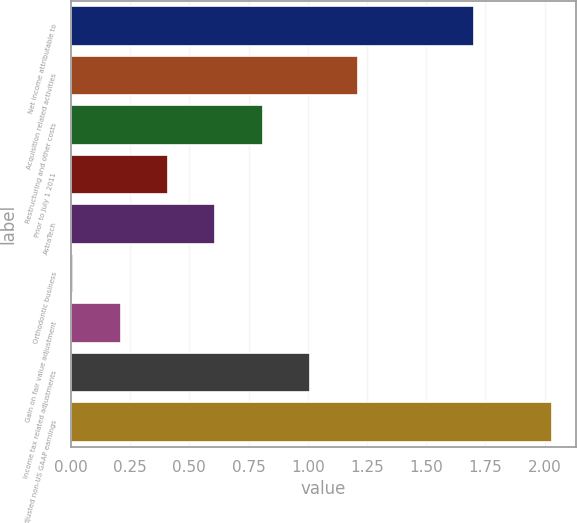<chart> <loc_0><loc_0><loc_500><loc_500><bar_chart><fcel>Net income attributable to<fcel>Acquisition related activities<fcel>Restructuring and other costs<fcel>Prior to July 1 2011<fcel>AstraTech<fcel>Orthodontic business<fcel>Gain on fair value adjustment<fcel>Income tax related adjustments<fcel>Adjusted non-US GAAP earnings<nl><fcel>1.7<fcel>1.21<fcel>0.81<fcel>0.41<fcel>0.61<fcel>0.01<fcel>0.21<fcel>1.01<fcel>2.03<nl></chart> 